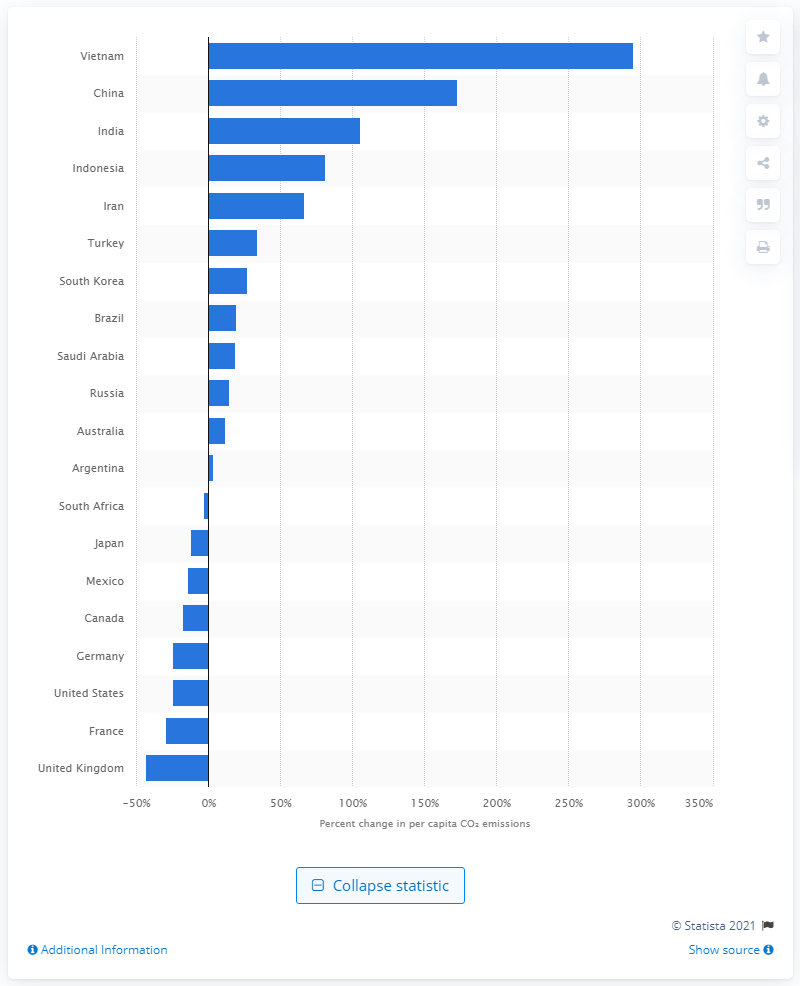List a handful of essential elements in this visual. The neighboring country of Vietnam has also seen significant growth in per capita emissions, a trend that has been observed in other countries as well. 